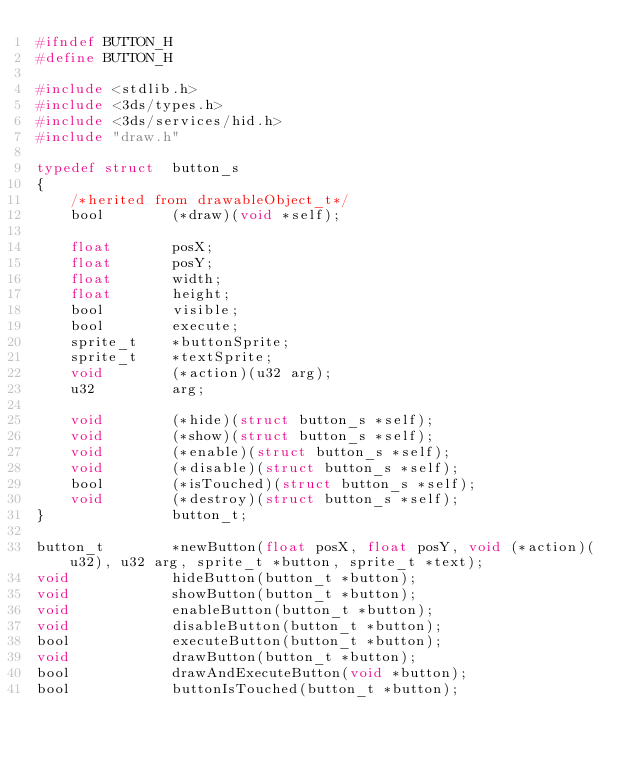Convert code to text. <code><loc_0><loc_0><loc_500><loc_500><_C_>#ifndef BUTTON_H
#define BUTTON_H

#include <stdlib.h>
#include <3ds/types.h>
#include <3ds/services/hid.h>
#include "draw.h"

typedef struct  button_s
{
    /*herited from drawableObject_t*/
    bool        (*draw)(void *self);

    float       posX;
    float       posY;
    float       width;
    float       height;
    bool        visible;
    bool        execute;
    sprite_t    *buttonSprite;
    sprite_t    *textSprite;
    void        (*action)(u32 arg);
    u32         arg;

    void        (*hide)(struct button_s *self);
    void        (*show)(struct button_s *self);
    void        (*enable)(struct button_s *self);
    void        (*disable)(struct button_s *self);
    bool        (*isTouched)(struct button_s *self);
    void        (*destroy)(struct button_s *self);
}               button_t;

button_t        *newButton(float posX, float posY, void (*action)(u32), u32 arg, sprite_t *button, sprite_t *text);
void            hideButton(button_t *button);
void            showButton(button_t *button);
void            enableButton(button_t *button);
void            disableButton(button_t *button);
bool            executeButton(button_t *button);
void            drawButton(button_t *button);
bool            drawAndExecuteButton(void *button);
bool            buttonIsTouched(button_t *button);</code> 